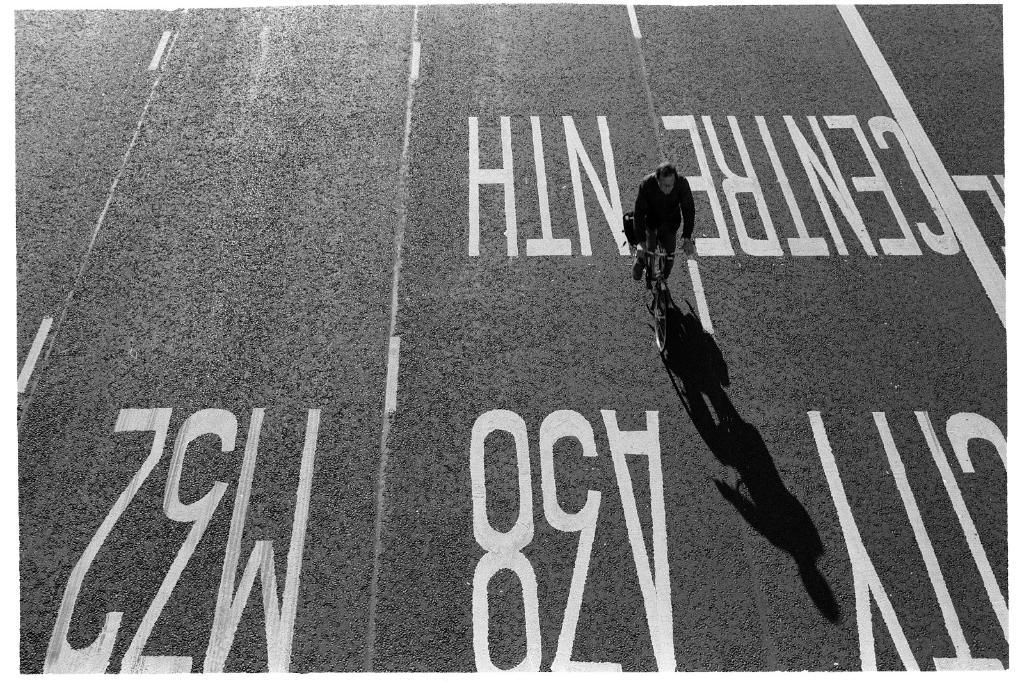Provide a one-sentence caption for the provided image. A man on a bicycle rides down central north street. 